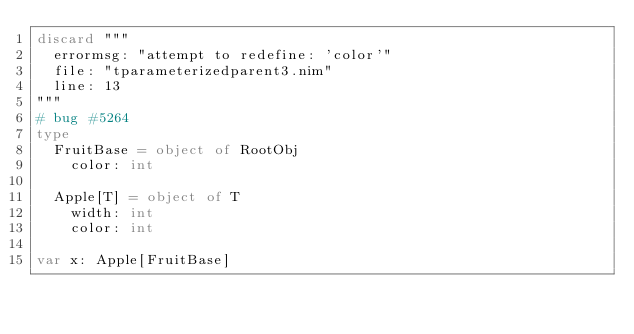Convert code to text. <code><loc_0><loc_0><loc_500><loc_500><_Nim_>discard """
  errormsg: "attempt to redefine: 'color'"
  file: "tparameterizedparent3.nim"
  line: 13
"""
# bug #5264
type
  FruitBase = object of RootObj
    color: int

  Apple[T] = object of T
    width: int
    color: int

var x: Apple[FruitBase]
</code> 